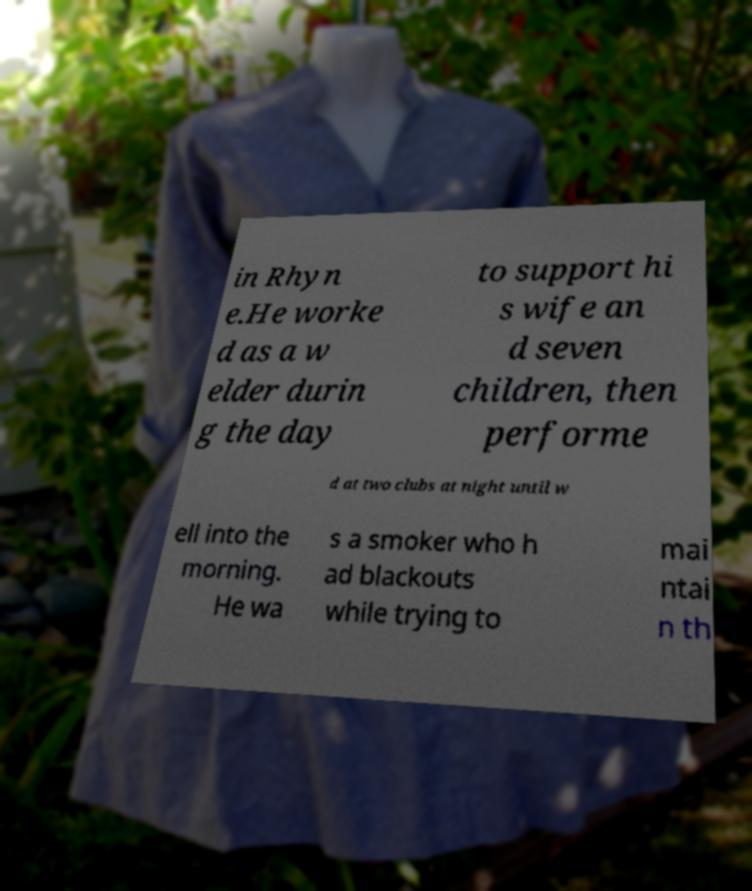Could you assist in decoding the text presented in this image and type it out clearly? in Rhyn e.He worke d as a w elder durin g the day to support hi s wife an d seven children, then performe d at two clubs at night until w ell into the morning. He wa s a smoker who h ad blackouts while trying to mai ntai n th 